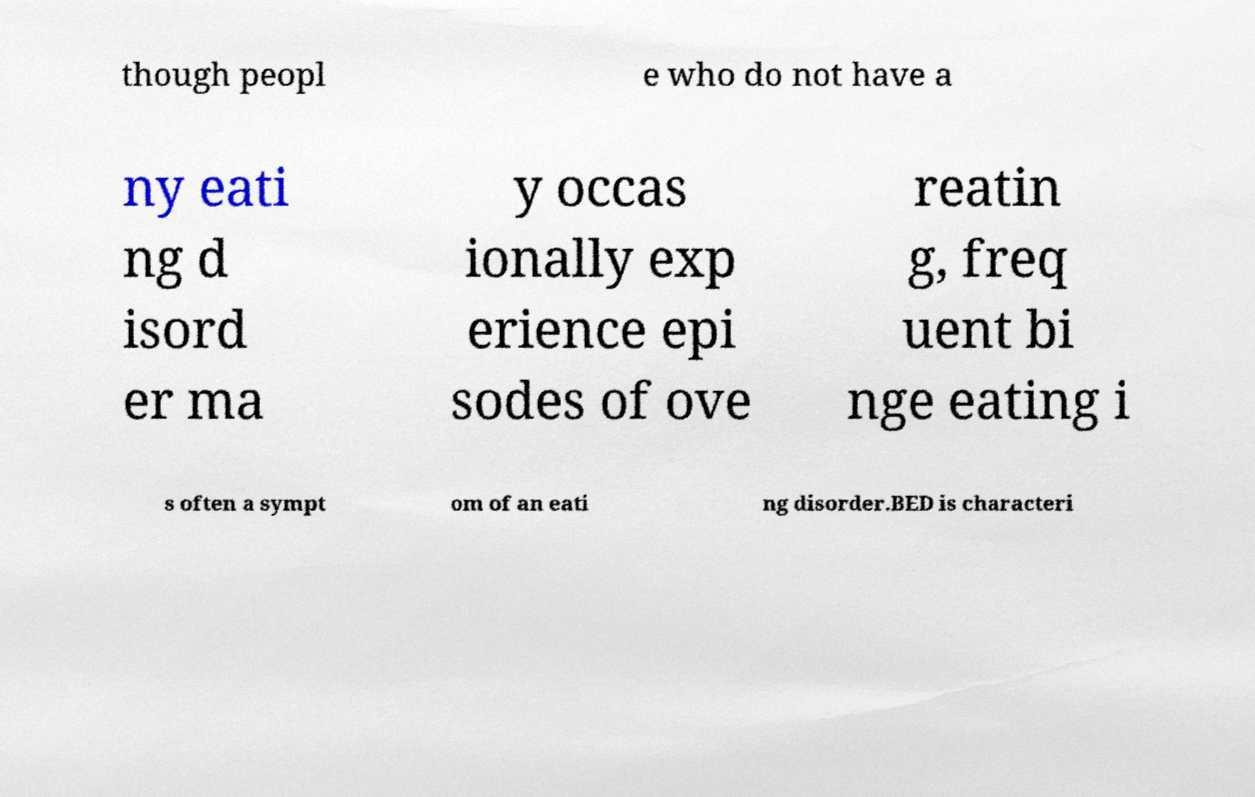Could you extract and type out the text from this image? though peopl e who do not have a ny eati ng d isord er ma y occas ionally exp erience epi sodes of ove reatin g, freq uent bi nge eating i s often a sympt om of an eati ng disorder.BED is characteri 